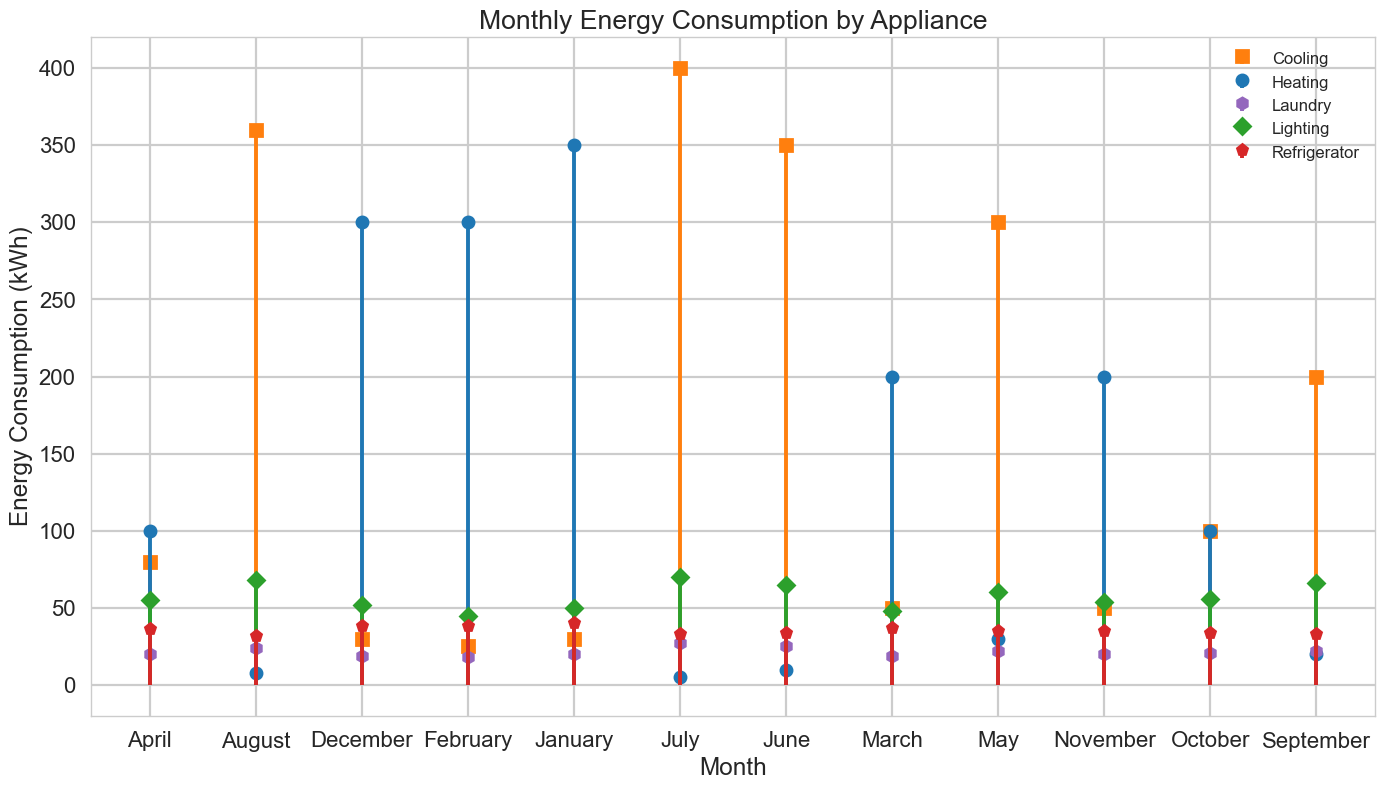What is the highest monthly energy consumption for Cooling? The highest monthly energy consumption for Cooling can be found by comparing all the values under the Cooling category. From the plot, the highest value is in July with 400 kWh.
Answer: 400 kWh Which appliance has the most stable energy consumption throughout the year? To identify the most stable appliance, observe the lines in the stem plot. The Refrigerator’s energy consumption values are relatively flat and consistent across all months compared to other appliances.
Answer: Refrigerator During which month is the difference between Heating and Cooling consumption the largest? Comparing the Heating and Cooling values for each month, it appears the difference is the largest in January, with Heating at 350 kWh and Cooling at 30 kWh. The difference is 320 kWh.
Answer: January Which month has the lowest total energy consumption across all appliances? Sum the energy consumption of all appliances for each month and identify the lowest total. By evaluating the figure, June has the lowest total energy consumption.
Answer: June Which months have higher energy consumption for Cooling than Heating? Compare monthly Cooling and Heating values. May, June, July, August, and September have higher energy consumption for Cooling than Heating.
Answer: May, June, July, August, September How does the energy consumption for Lighting trend over the year? Observe the markers for Lighting. The energy consumption for Lighting starts at 50 kWh in January, peaks in July at 70 kWh, and gently declines towards the later months.
Answer: Rises then falls What is the total energy consumption for Laundry in the second half of the year (July to December)? Add Laundry's energy consumption from July to December: 27 + 24 + 22 + 21 + 20 + 19 = 133 kWh.
Answer: 133 kWh Which appliance exhibits the highest variability in energy consumption across different months? To identify the appliance with the highest variability, look at the spread in the stem plot markers. Cooling shows the largest range from 25 to 400 kWh, indicating high variability.
Answer: Cooling During which month is the overall energy consumption the highest? Sum the energy consumption of all appliances for each month and identify the highest total. July, with high values across Cooling, Lighting, Refrigerator, and Laundry (no single appliance dominates), shows the highest total.
Answer: July In which months does the Heating appliance have zero or near-zero energy consumption? Look for months where the Heating markers are at or close to the x-axis. June and July have Heating consumption values of 10 kWh and 5 kWh, respectively.
Answer: June, July 